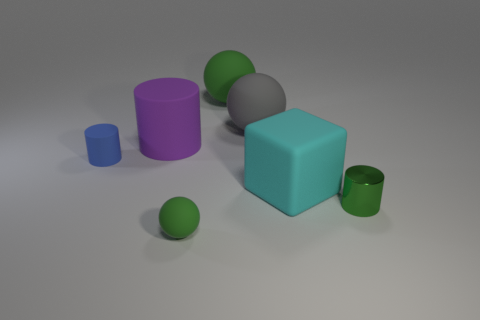Add 1 tiny cylinders. How many objects exist? 8 Subtract all blocks. How many objects are left? 6 Subtract 0 brown cylinders. How many objects are left? 7 Subtract all gray balls. Subtract all big green rubber spheres. How many objects are left? 5 Add 4 big cyan things. How many big cyan things are left? 5 Add 1 large purple rubber cylinders. How many large purple rubber cylinders exist? 2 